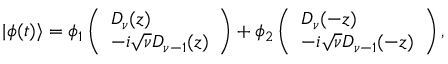<formula> <loc_0><loc_0><loc_500><loc_500>| \phi ( t ) \rangle = \phi _ { 1 } \left ( \begin{array} { l } { D _ { \nu } ( z ) } \\ { - i \sqrt { \nu } D _ { \nu - 1 } ( z ) } \end{array} \right ) + \phi _ { 2 } \left ( \begin{array} { l } { D _ { \nu } ( - z ) } \\ { - i \sqrt { \nu } D _ { \nu - 1 } ( - z ) } \end{array} \right ) ,</formula> 